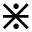<formula> <loc_0><loc_0><loc_500><loc_500>\divideontimes</formula> 